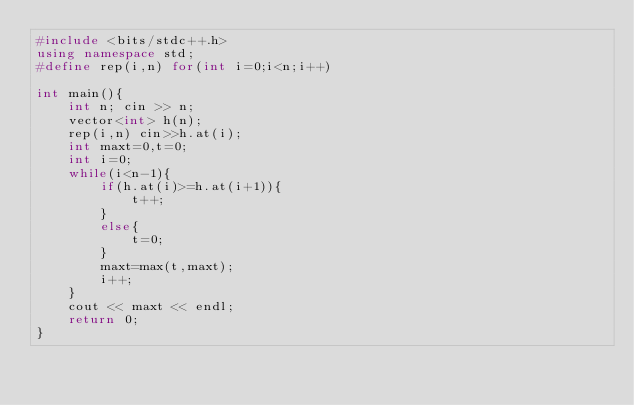<code> <loc_0><loc_0><loc_500><loc_500><_C++_>#include <bits/stdc++.h>
using namespace std;
#define rep(i,n) for(int i=0;i<n;i++)

int main(){
    int n; cin >> n;
    vector<int> h(n);
    rep(i,n) cin>>h.at(i);
    int maxt=0,t=0;
    int i=0;
    while(i<n-1){
        if(h.at(i)>=h.at(i+1)){
            t++;
        }
        else{
            t=0;
        }
        maxt=max(t,maxt);
        i++;
    }
    cout << maxt << endl;
    return 0;
}</code> 